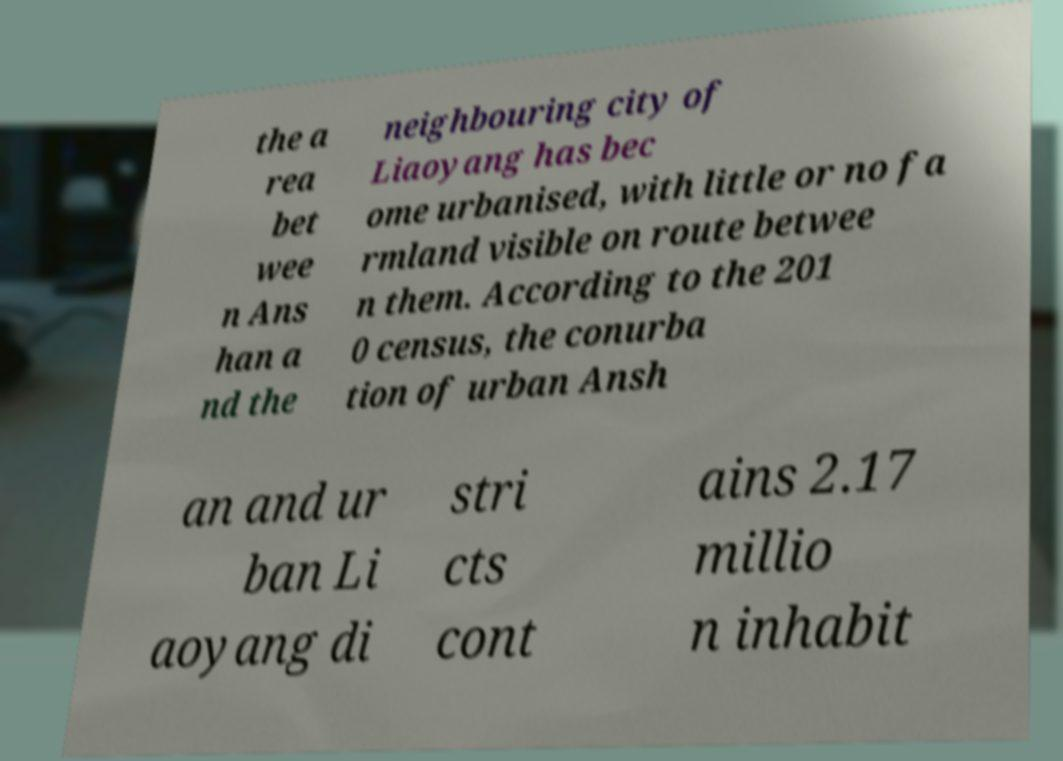What messages or text are displayed in this image? I need them in a readable, typed format. the a rea bet wee n Ans han a nd the neighbouring city of Liaoyang has bec ome urbanised, with little or no fa rmland visible on route betwee n them. According to the 201 0 census, the conurba tion of urban Ansh an and ur ban Li aoyang di stri cts cont ains 2.17 millio n inhabit 